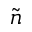Convert formula to latex. <formula><loc_0><loc_0><loc_500><loc_500>\tilde { n }</formula> 